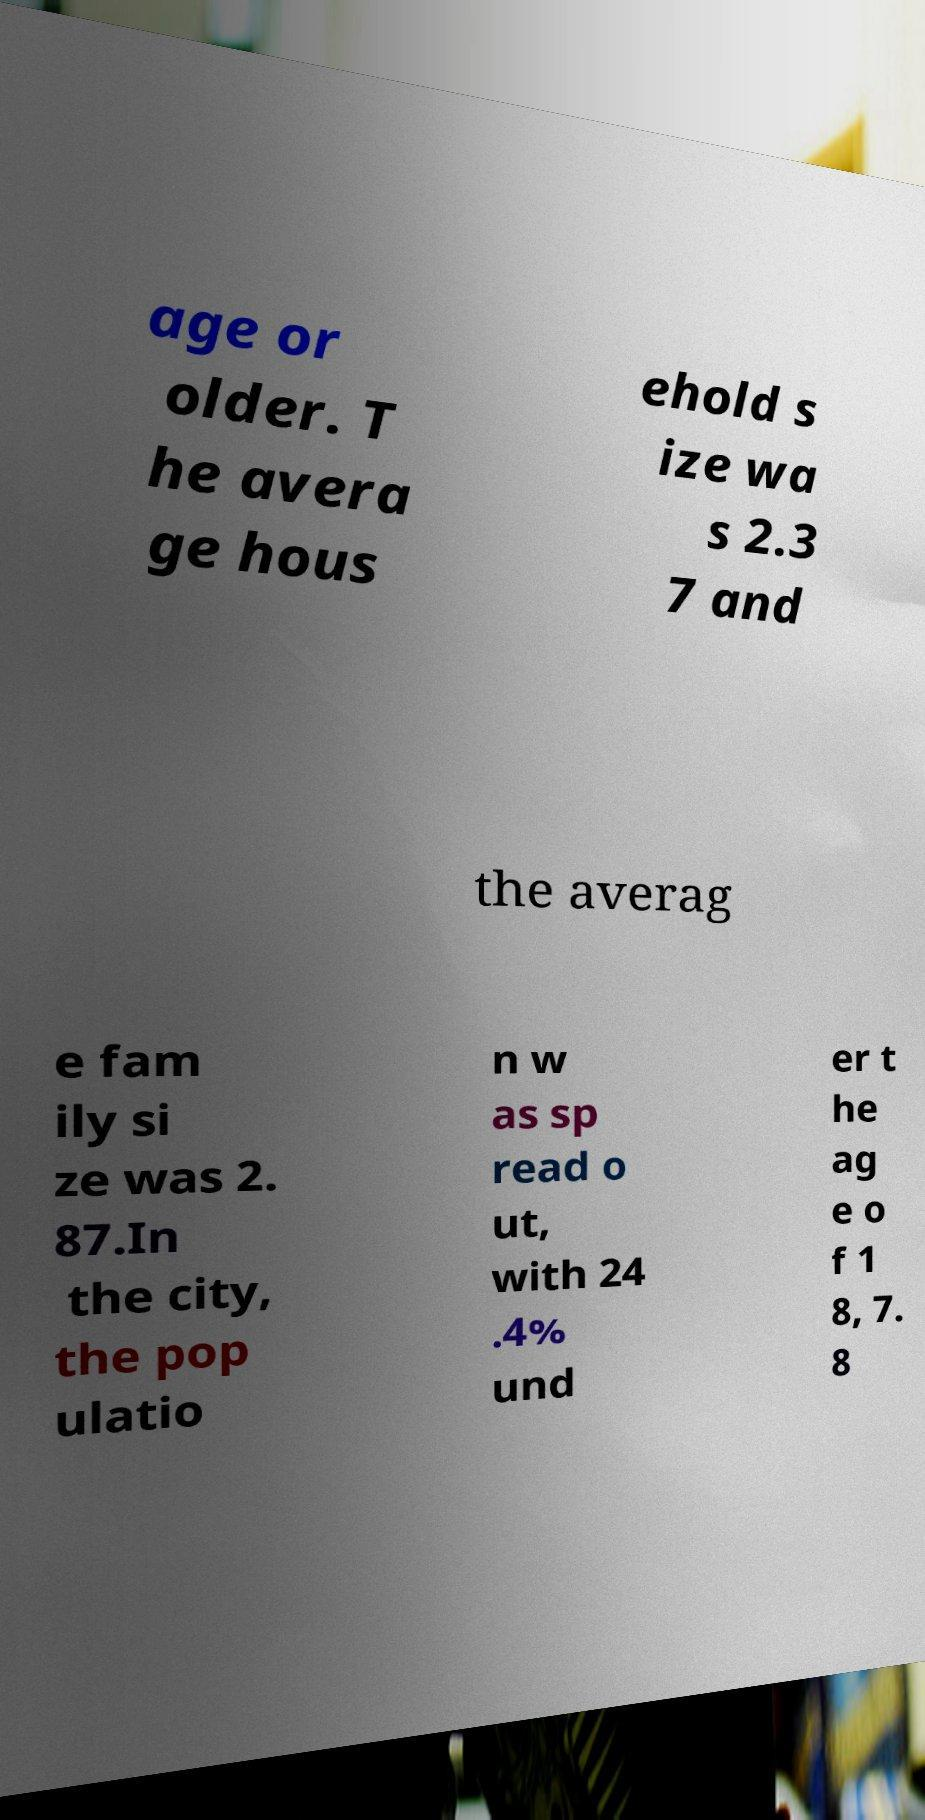Could you extract and type out the text from this image? age or older. T he avera ge hous ehold s ize wa s 2.3 7 and the averag e fam ily si ze was 2. 87.In the city, the pop ulatio n w as sp read o ut, with 24 .4% und er t he ag e o f 1 8, 7. 8 